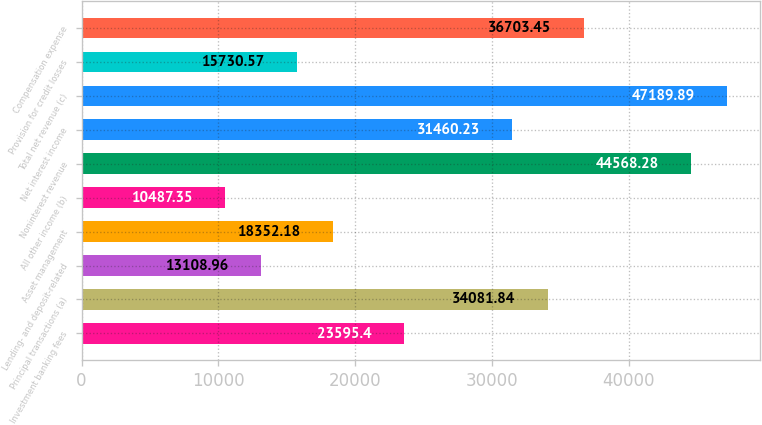Convert chart. <chart><loc_0><loc_0><loc_500><loc_500><bar_chart><fcel>Investment banking fees<fcel>Principal transactions (a)<fcel>Lending- and deposit-related<fcel>Asset management<fcel>All other income (b)<fcel>Noninterest revenue<fcel>Net interest income<fcel>Total net revenue (c)<fcel>Provision for credit losses<fcel>Compensation expense<nl><fcel>23595.4<fcel>34081.8<fcel>13109<fcel>18352.2<fcel>10487.4<fcel>44568.3<fcel>31460.2<fcel>47189.9<fcel>15730.6<fcel>36703.4<nl></chart> 